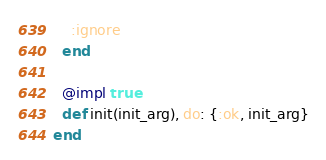Convert code to text. <code><loc_0><loc_0><loc_500><loc_500><_Elixir_>    :ignore
  end

  @impl true
  def init(init_arg), do: {:ok, init_arg}
end
</code> 